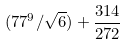Convert formula to latex. <formula><loc_0><loc_0><loc_500><loc_500>( 7 7 ^ { 9 } / \sqrt { 6 } ) + \frac { 3 1 4 } { 2 7 2 }</formula> 